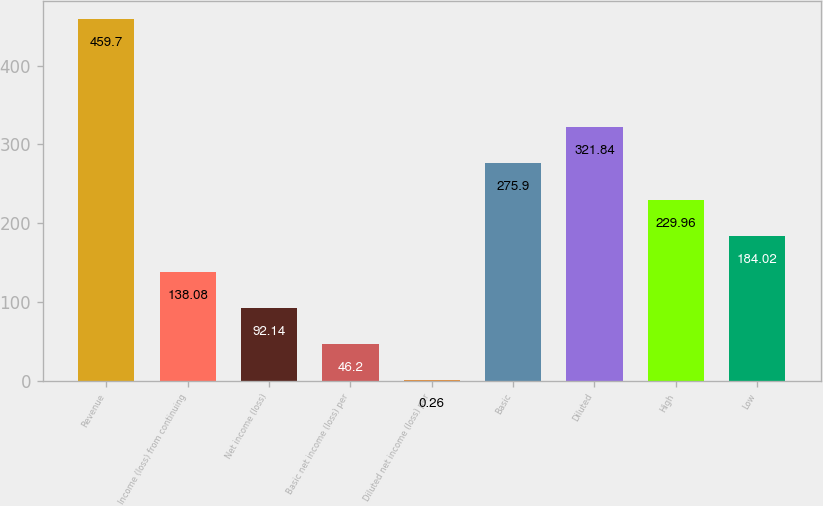<chart> <loc_0><loc_0><loc_500><loc_500><bar_chart><fcel>Revenue<fcel>Income (loss) from continuing<fcel>Net income (loss)<fcel>Basic net income (loss) per<fcel>Diluted net income (loss) per<fcel>Basic<fcel>Diluted<fcel>High<fcel>Low<nl><fcel>459.7<fcel>138.08<fcel>92.14<fcel>46.2<fcel>0.26<fcel>275.9<fcel>321.84<fcel>229.96<fcel>184.02<nl></chart> 